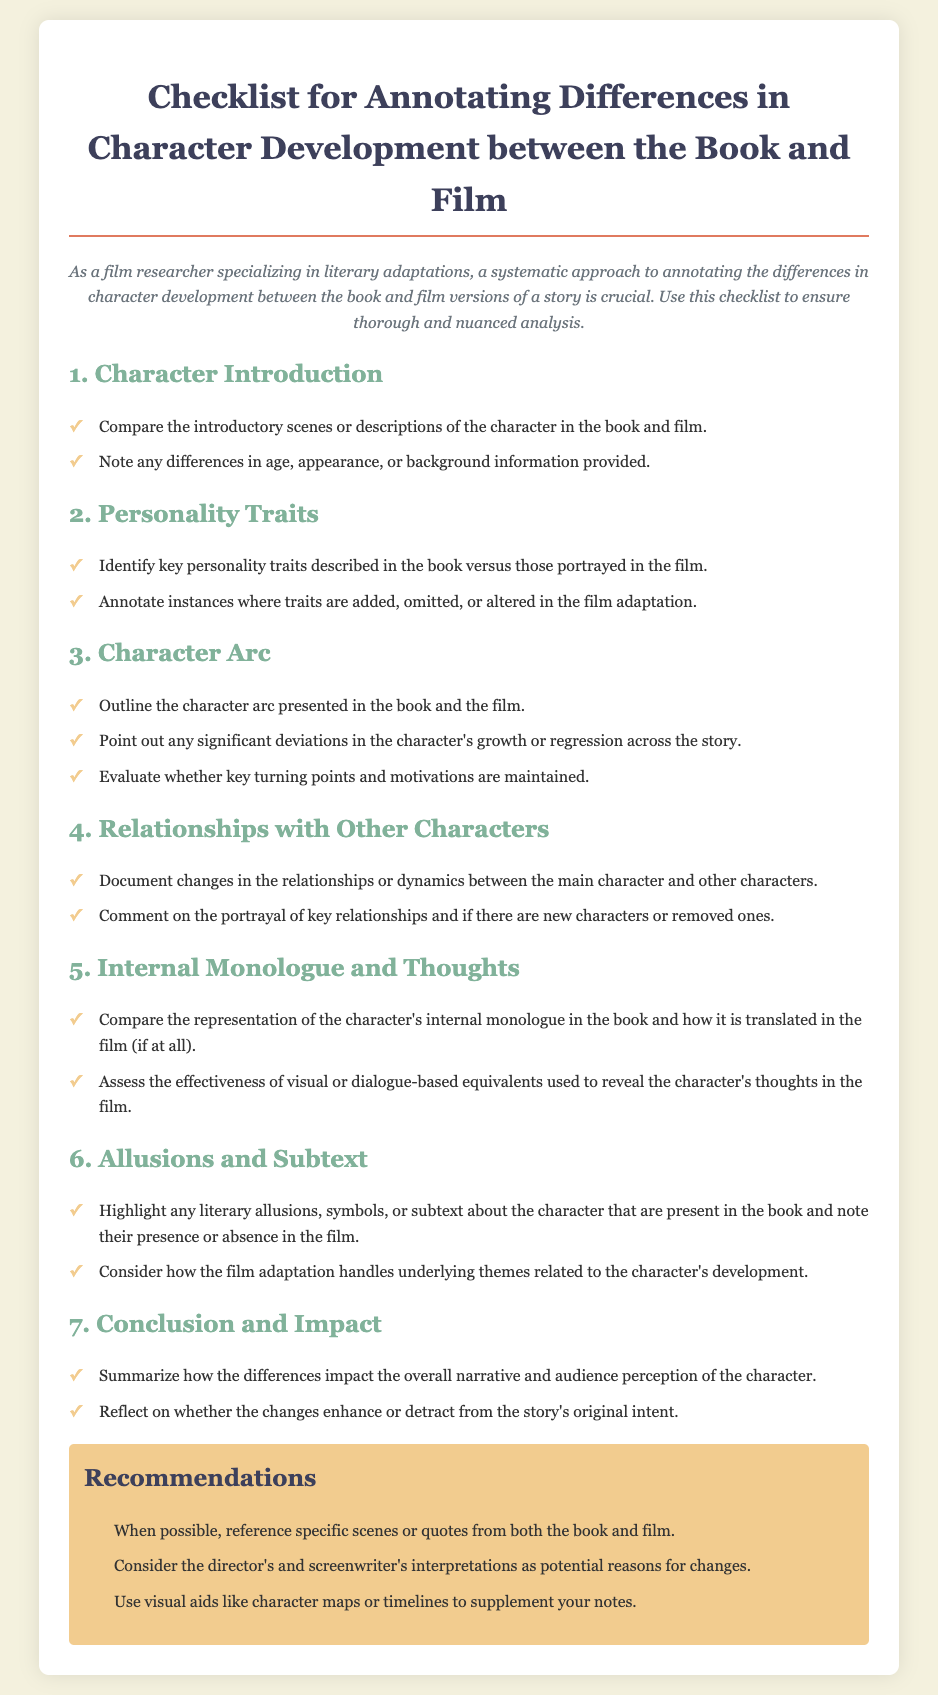What is the title of the checklist? The title is found at the top of the document and indicates the main focus of the content.
Answer: Checklist for Annotating Differences in Character Development between the Book and Film How many main sections are there in the checklist? The document outlines the main categories under which character development is analyzed, counted as individual sections.
Answer: 6 What should you compare in the section on Internal Monologue and Thoughts? This section suggests specific aspects to analyze regarding character thoughts, providing a focused inquiry topic in the checklist.
Answer: Representation of the character's internal monologue Which section outlines the character's growth or regression? This section specifically discusses the trajectory or changes in a character across the story, indicating where to look for such development.
Answer: Character Arc What is recommended to enhance notes according to the Recommendations section? The Recommendations provide practical tools to improve the annotation process, thus encouraging a thorough analysis of character development.
Answer: Visual aids like character maps or timelines What color is used for the recommendations box? This detail describes the visual aspect of the document, highlighting how specific sections are styled to enhance readability.
Answer: F2cc8f 